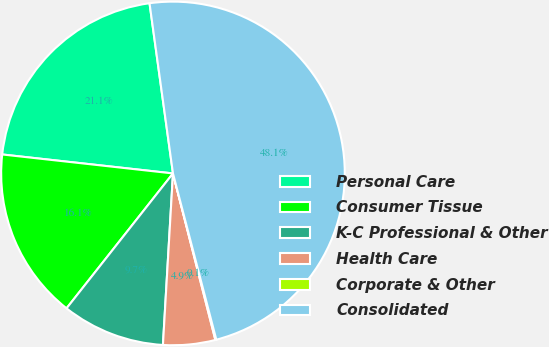Convert chart. <chart><loc_0><loc_0><loc_500><loc_500><pie_chart><fcel>Personal Care<fcel>Consumer Tissue<fcel>K-C Professional & Other<fcel>Health Care<fcel>Corporate & Other<fcel>Consolidated<nl><fcel>21.06%<fcel>16.13%<fcel>9.7%<fcel>4.9%<fcel>0.09%<fcel>48.12%<nl></chart> 